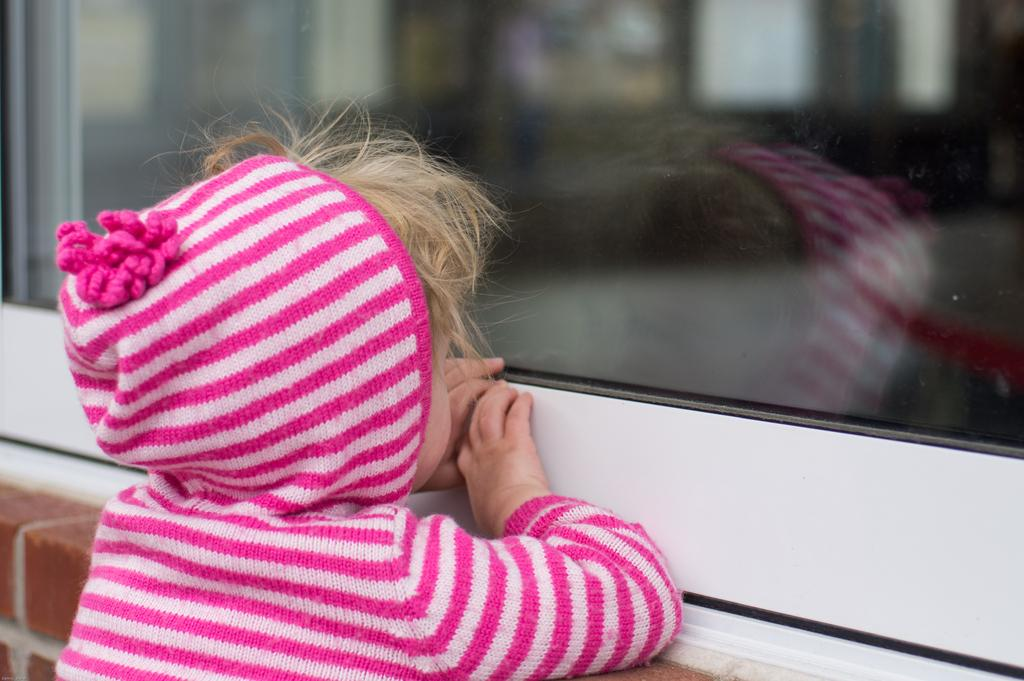What is the main subject in the foreground of the picture? There is a kid in the foreground of the picture. What is the kid wearing? The kid is wearing a pink jacket. What can be seen behind the kid? The kid is standing near a brick wall. What object is the kid holding? The kid is holding a glass window. What type of government is depicted in the image? There is no depiction of a government in the image; it features a kid wearing a pink jacket, standing near a brick wall, and holding a glass window. 